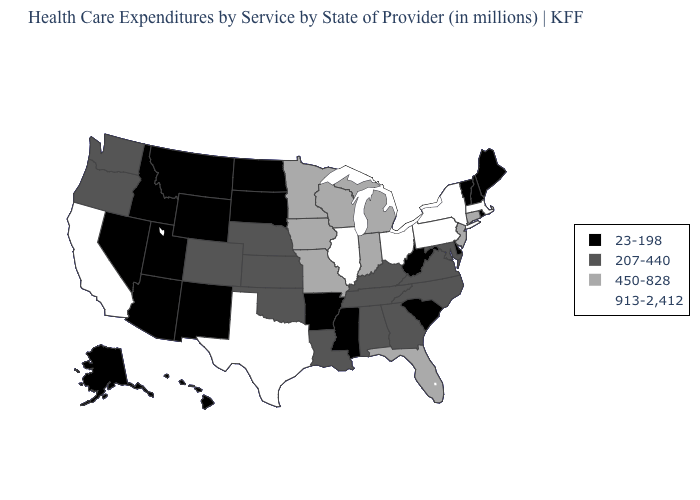Name the states that have a value in the range 450-828?
Give a very brief answer. Connecticut, Florida, Indiana, Iowa, Michigan, Minnesota, Missouri, New Jersey, Wisconsin. How many symbols are there in the legend?
Concise answer only. 4. What is the value of Illinois?
Write a very short answer. 913-2,412. What is the highest value in states that border Illinois?
Quick response, please. 450-828. Name the states that have a value in the range 913-2,412?
Quick response, please. California, Illinois, Massachusetts, New York, Ohio, Pennsylvania, Texas. What is the value of Louisiana?
Write a very short answer. 207-440. Among the states that border Tennessee , which have the highest value?
Write a very short answer. Missouri. What is the lowest value in the South?
Answer briefly. 23-198. What is the value of Georgia?
Write a very short answer. 207-440. Name the states that have a value in the range 913-2,412?
Keep it brief. California, Illinois, Massachusetts, New York, Ohio, Pennsylvania, Texas. What is the highest value in the USA?
Answer briefly. 913-2,412. Does Maine have a lower value than Idaho?
Quick response, please. No. Does Nebraska have the same value as South Carolina?
Concise answer only. No. Does Nebraska have the lowest value in the USA?
Short answer required. No. 